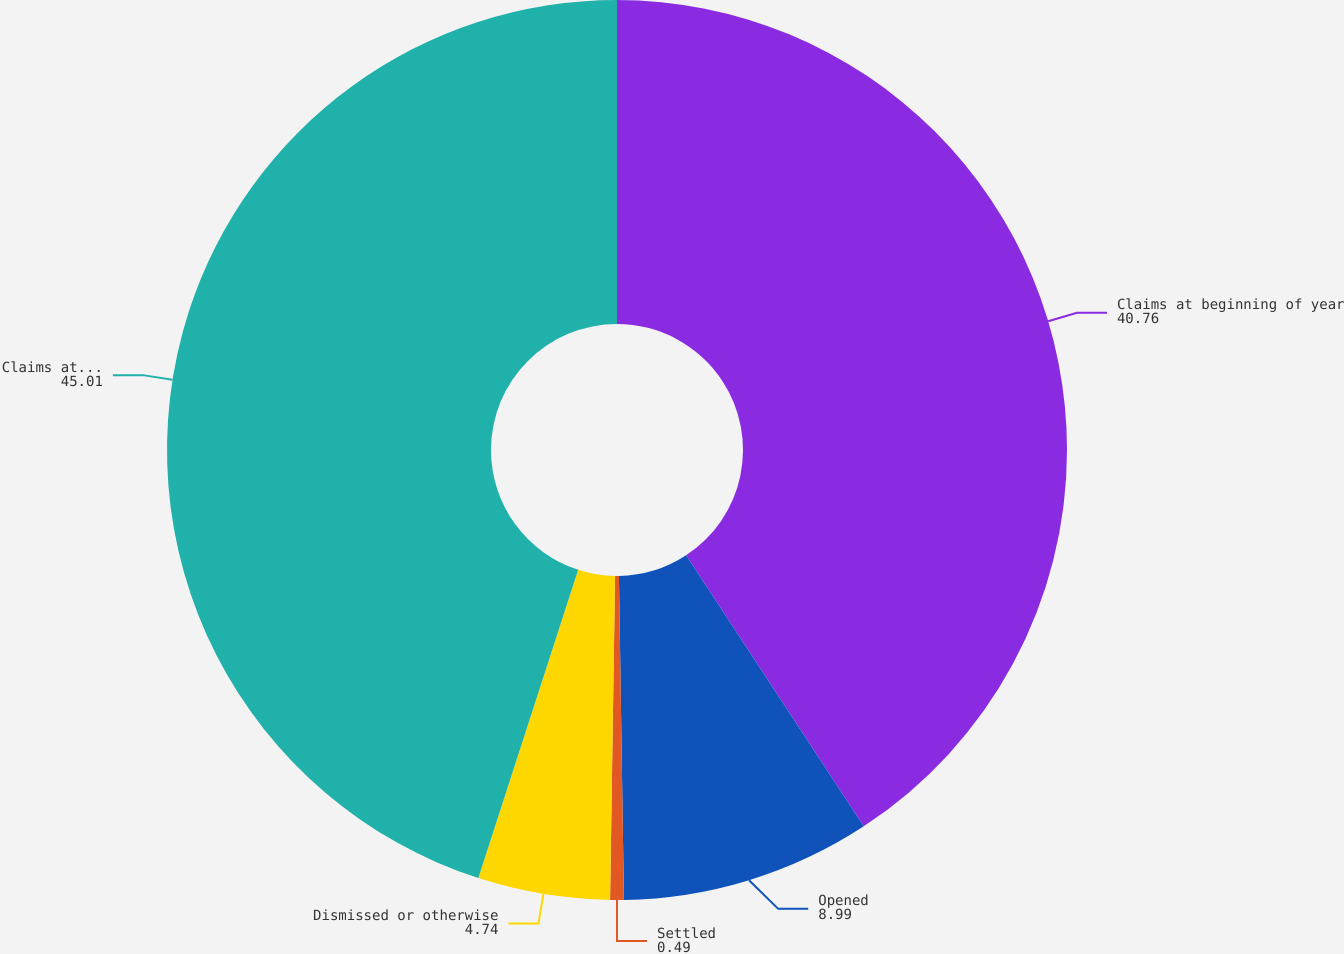Convert chart to OTSL. <chart><loc_0><loc_0><loc_500><loc_500><pie_chart><fcel>Claims at beginning of year<fcel>Opened<fcel>Settled<fcel>Dismissed or otherwise<fcel>Claims at end of year<nl><fcel>40.76%<fcel>8.99%<fcel>0.49%<fcel>4.74%<fcel>45.01%<nl></chart> 